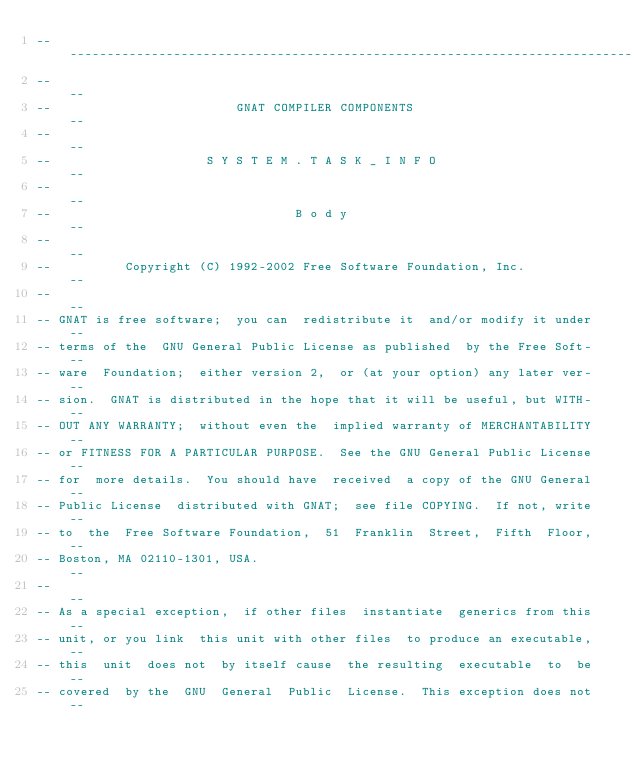<code> <loc_0><loc_0><loc_500><loc_500><_Ada_>------------------------------------------------------------------------------
--                                                                          --
--                         GNAT COMPILER COMPONENTS                         --
--                                                                          --
--                     S Y S T E M . T A S K _ I N F O                      --
--                                                                          --
--                                 B o d y                                  --
--                                                                          --
--          Copyright (C) 1992-2002 Free Software Foundation, Inc.          --
--                                                                          --
-- GNAT is free software;  you can  redistribute it  and/or modify it under --
-- terms of the  GNU General Public License as published  by the Free Soft- --
-- ware  Foundation;  either version 2,  or (at your option) any later ver- --
-- sion.  GNAT is distributed in the hope that it will be useful, but WITH- --
-- OUT ANY WARRANTY;  without even the  implied warranty of MERCHANTABILITY --
-- or FITNESS FOR A PARTICULAR PURPOSE.  See the GNU General Public License --
-- for  more details.  You should have  received  a copy of the GNU General --
-- Public License  distributed with GNAT;  see file COPYING.  If not, write --
-- to  the  Free Software Foundation,  51  Franklin  Street,  Fifth  Floor, --
-- Boston, MA 02110-1301, USA.                                              --
--                                                                          --
-- As a special exception,  if other files  instantiate  generics from this --
-- unit, or you link  this unit with other files  to produce an executable, --
-- this  unit  does not  by itself cause  the resulting  executable  to  be --
-- covered  by the  GNU  General  Public  License.  This exception does not --</code> 